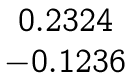<formula> <loc_0><loc_0><loc_500><loc_500>\begin{matrix} 0 . 2 3 2 4 \\ - 0 . 1 2 3 6 \end{matrix}</formula> 